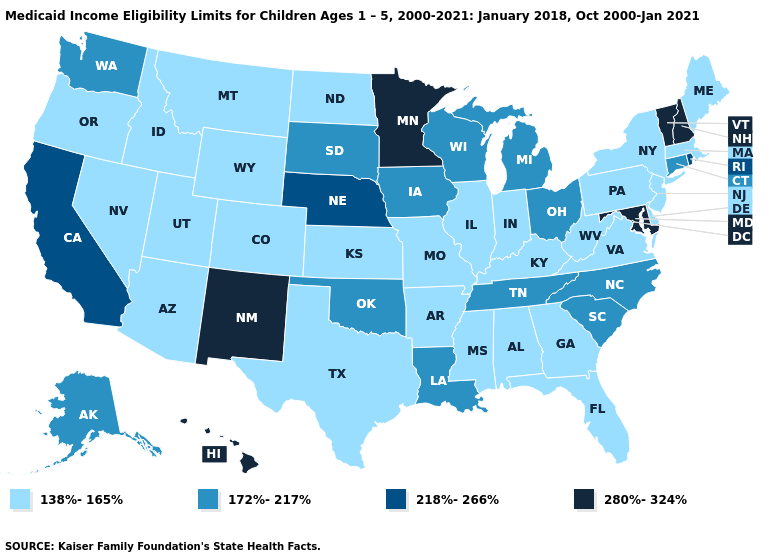Does the first symbol in the legend represent the smallest category?
Give a very brief answer. Yes. Name the states that have a value in the range 172%-217%?
Short answer required. Alaska, Connecticut, Iowa, Louisiana, Michigan, North Carolina, Ohio, Oklahoma, South Carolina, South Dakota, Tennessee, Washington, Wisconsin. Does the map have missing data?
Be succinct. No. Name the states that have a value in the range 172%-217%?
Write a very short answer. Alaska, Connecticut, Iowa, Louisiana, Michigan, North Carolina, Ohio, Oklahoma, South Carolina, South Dakota, Tennessee, Washington, Wisconsin. Does Illinois have the lowest value in the MidWest?
Write a very short answer. Yes. What is the value of Georgia?
Short answer required. 138%-165%. What is the value of Utah?
Quick response, please. 138%-165%. What is the highest value in states that border Illinois?
Answer briefly. 172%-217%. Does Iowa have the lowest value in the MidWest?
Be succinct. No. Is the legend a continuous bar?
Be succinct. No. Does South Dakota have the lowest value in the MidWest?
Give a very brief answer. No. Which states have the lowest value in the Northeast?
Give a very brief answer. Maine, Massachusetts, New Jersey, New York, Pennsylvania. Name the states that have a value in the range 218%-266%?
Be succinct. California, Nebraska, Rhode Island. Among the states that border Nebraska , does Wyoming have the lowest value?
Keep it brief. Yes. What is the highest value in the South ?
Keep it brief. 280%-324%. 